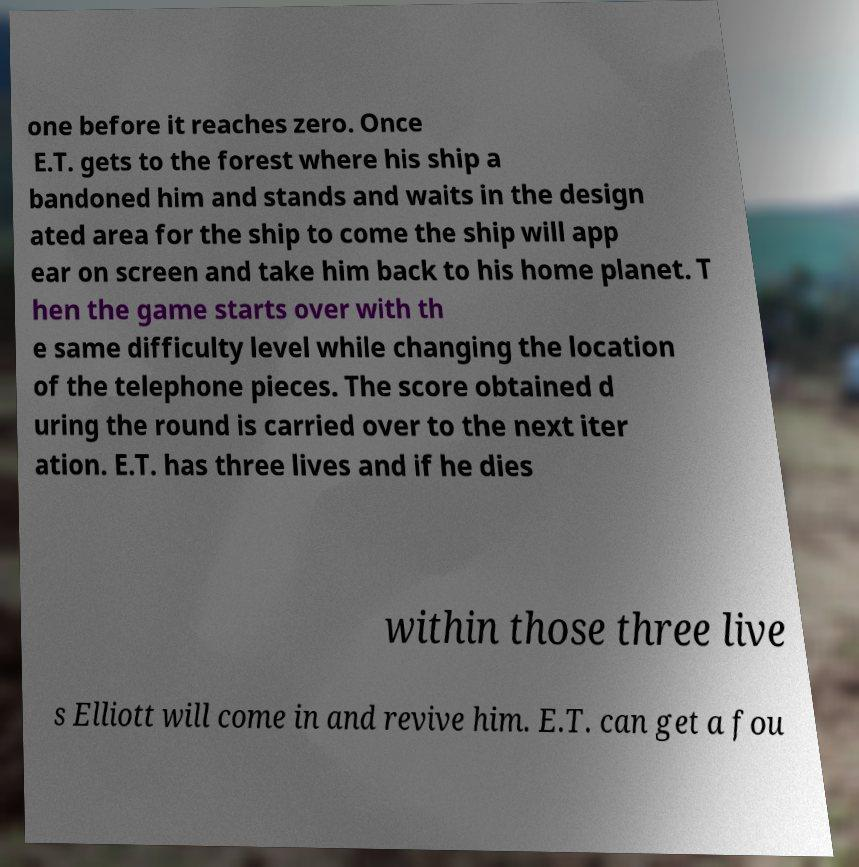Could you assist in decoding the text presented in this image and type it out clearly? one before it reaches zero. Once E.T. gets to the forest where his ship a bandoned him and stands and waits in the design ated area for the ship to come the ship will app ear on screen and take him back to his home planet. T hen the game starts over with th e same difficulty level while changing the location of the telephone pieces. The score obtained d uring the round is carried over to the next iter ation. E.T. has three lives and if he dies within those three live s Elliott will come in and revive him. E.T. can get a fou 